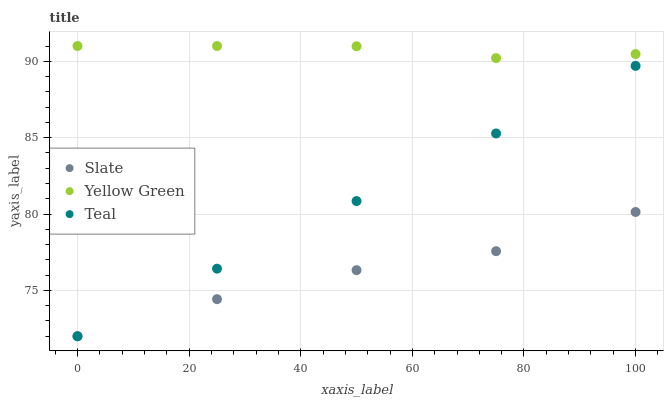Does Slate have the minimum area under the curve?
Answer yes or no. Yes. Does Yellow Green have the maximum area under the curve?
Answer yes or no. Yes. Does Teal have the minimum area under the curve?
Answer yes or no. No. Does Teal have the maximum area under the curve?
Answer yes or no. No. Is Teal the smoothest?
Answer yes or no. Yes. Is Slate the roughest?
Answer yes or no. Yes. Is Yellow Green the smoothest?
Answer yes or no. No. Is Yellow Green the roughest?
Answer yes or no. No. Does Slate have the lowest value?
Answer yes or no. Yes. Does Yellow Green have the lowest value?
Answer yes or no. No. Does Yellow Green have the highest value?
Answer yes or no. Yes. Does Teal have the highest value?
Answer yes or no. No. Is Teal less than Yellow Green?
Answer yes or no. Yes. Is Yellow Green greater than Slate?
Answer yes or no. Yes. Does Slate intersect Teal?
Answer yes or no. Yes. Is Slate less than Teal?
Answer yes or no. No. Is Slate greater than Teal?
Answer yes or no. No. Does Teal intersect Yellow Green?
Answer yes or no. No. 